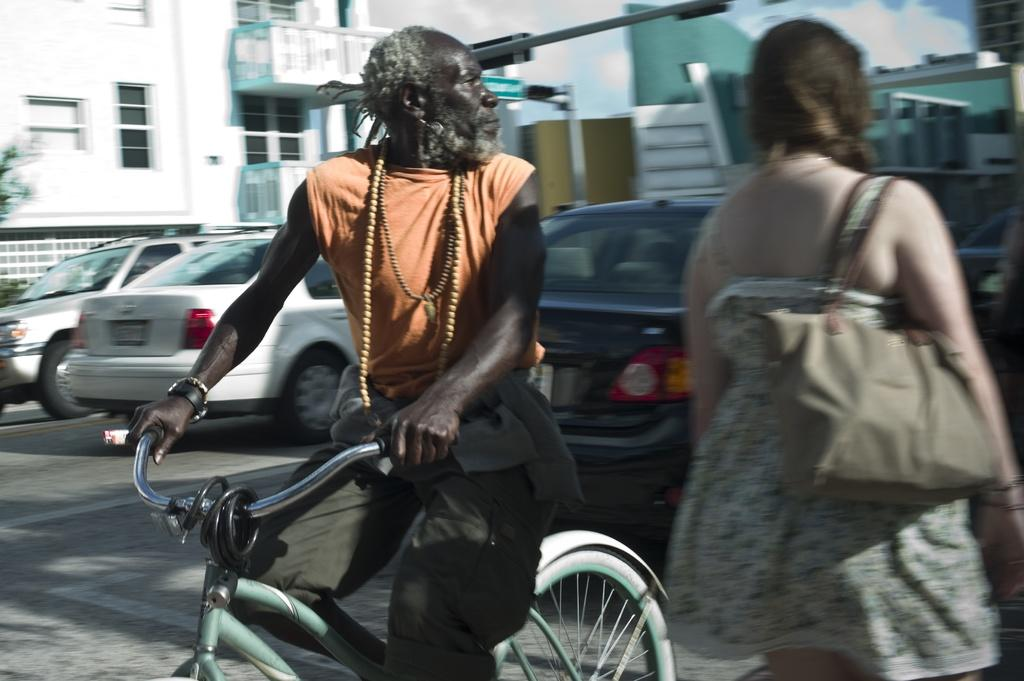What is the man in the image doing? The man is on a cycle in the image. What is the woman in the image carrying? The woman is carrying a bag in the image. What can be seen in the background of the image? There are cars, buildings, and the sky visible in the background of the image. What type of tin can be seen hanging from the cycle in the image? There is no tin present in the image; the man is on a cycle, and the woman is carrying a bag. 